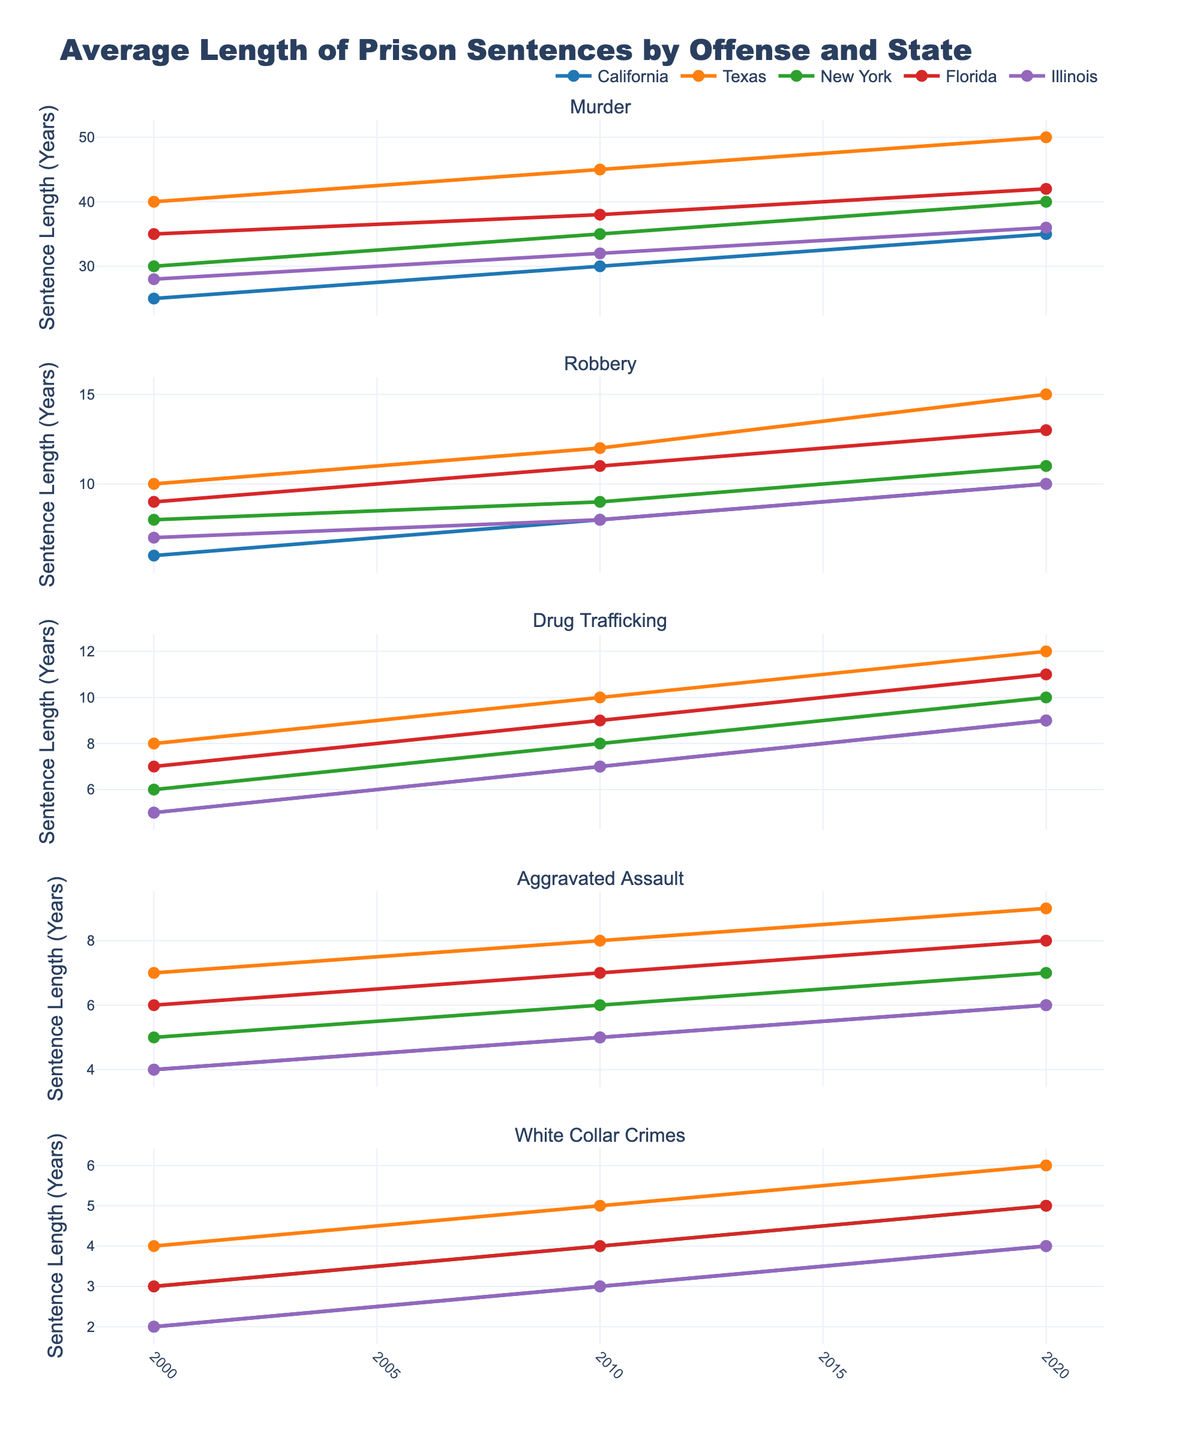What is the trend in the average length of prison sentences for murder in California from 2000 to 2020? Look at the subplot corresponding to "Murder" and the line for "California." Observe the data points from 2000 to 2020 to see how the line progresses. The line shows an increasing trend from 25 years in 2000 to 35 years in 2020.
Answer: Increasing Which state has the highest average prison sentence for drug trafficking in 2020? Look at the subplot for "Drug Trafficking" and find the data point for 2020. Compare the heights of the lines for each state. Texas has the highest value with an average sentence of 12 years.
Answer: Texas How does the average length of prison sentences for white-collar crimes in Illinois compare to California in 2010? Find the subplot for "White Collar Crimes" and identify the data points for 2010. Compare the values for Illinois and California. Illinois has 3 years, and California has 3 years. Both are equal.
Answer: Equal By how many years did the average sentence for aggravated assault in Texas change from 2000 to 2010? Look at the subplot for "Aggravated Assault" and focus on Texas. Note the values for 2000 and 2010, which are 7 and 8 respectively. Calculate the difference, 8 - 7 = 1 year.
Answer: 1 year Among all the offenses, which state shows the maximum increase in average sentence length for robbery from 2000 to 2020? Go to the subplot for "Robbery" and compare the change from 2000 to 2020 for all states. Calculate the difference for each state: California (4), Texas (5), New York (3), Florida (4), and Illinois (3). Texas shows an increase of 5 years, the maximum.
Answer: Texas What is the difference in the average sentence lengths for robbery in New York and Florida in the year 2010? Locate the "Robbery" subplot and identify the data points for 2010 for New York and Florida. The values are 9 and 11, respectively. Calculate the difference: 11 - 9 = 2 years.
Answer: 2 years 